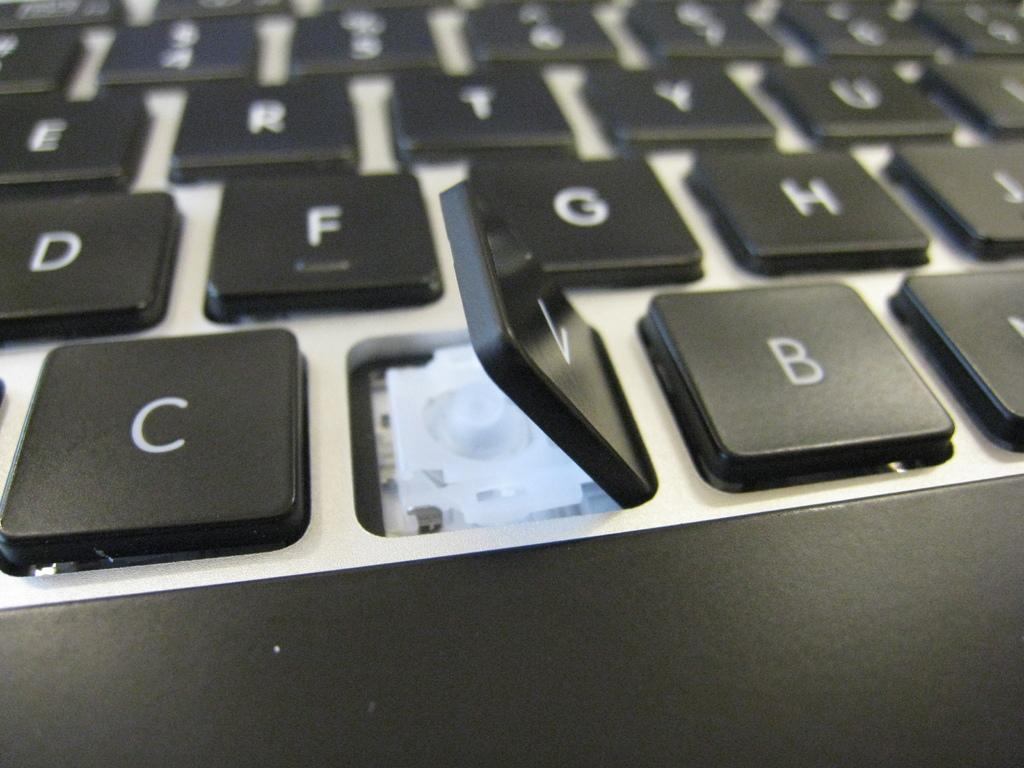<image>
Present a compact description of the photo's key features. A computer keyboard, with the letter V key raised up 